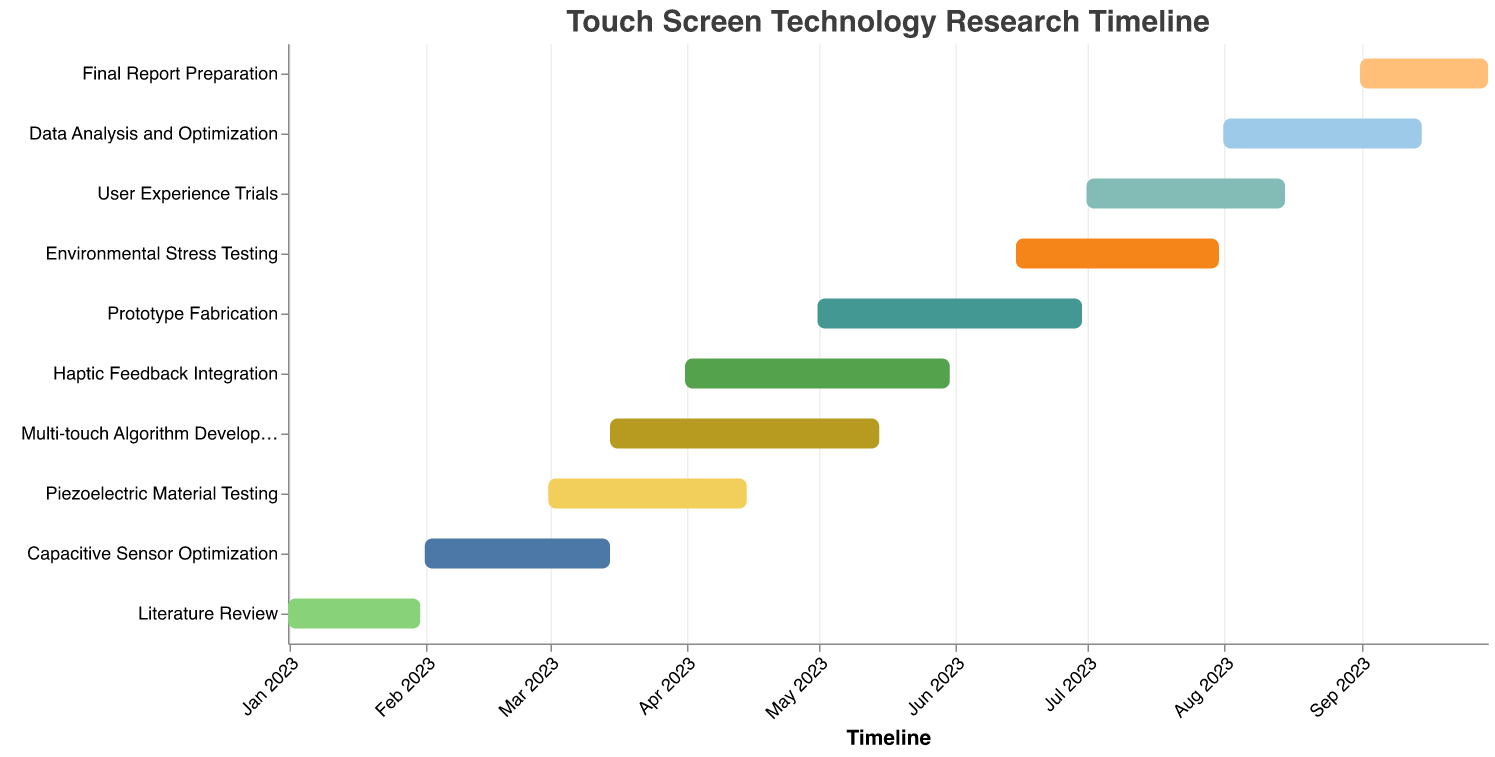What is the total duration of the "Capacitive Sensor Optimization" task? The task "Capacitive Sensor Optimization" spans from February 1, 2023, to March 15, 2023. This duration is also given directly as 43 days.
Answer: 43 days During which months does the "Haptic Feedback Integration" task occur? The "Haptic Feedback Integration" task starts in April 2023 and ends in May 2023.
Answer: April and May 2023 Which tasks overlap with "Multi-touch Algorithm Development"? "Multi-touch Algorithm Development" runs from March 15, 2023, to May 15, 2023. Tasks that overlap this period include "Piezoelectric Material Testing" (March 1, 2023, to April 15, 2023), and "Haptic Feedback Integration" (April 1, 2023, to May 31, 2023).
Answer: Piezoelectric Material Testing and Haptic Feedback Integration Which task has the longest duration, and how many days is it? To find the longest task duration, we compare the "Duration (days)" field for each task. "Multi-touch Algorithm Development" has the longest duration at 62 days.
Answer: Multi-touch Algorithm Development, 62 days What is the time gap between the end of "Literature Review" and the start of "Capacitive Sensor Optimization"? "Literature Review" ends on January 31, 2023, and "Capacitive Sensor Optimization" starts on February 1, 2023. The time gap between these dates is 1 day.
Answer: 1 day Which tasks start after "Prototype Fabrication" begins? "Prototype Fabrication" starts on May 1, 2023. Tasks that start after this date include "Environmental Stress Testing" (June 15, 2023), "User Experience Trials" (July 1, 2023), "Data Analysis and Optimization" (August 1, 2023), and "Final Report Preparation" (September 1, 2023).
Answer: Environmental Stress Testing, User Experience Trials, Data Analysis and Optimization, Final Report Preparation How many tasks are scheduled to take place during the month of July 2023? To determine the number of tasks occurring in July 2023, check the date ranges for overlapping periods. These tasks are "Environmental Stress Testing" (June 15, 2023 to July 31, 2023), "User Experience Trials" (July 1, 2023 to August 15, 2023).
Answer: 2 tasks What's the combined duration of "User Experience Trials" and "Data Analysis and Optimization"? "User Experience Trials" lasts for 46 days and "Data Analysis and Optimization" also lasts for 46 days. Adding the two, the combined duration is 46 + 46 = 92 days.
Answer: 92 days How many tasks are there in total? Count the number of distinct tasks listed in the data. There are a total of 10 tasks.
Answer: 10 tasks 